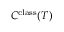Convert formula to latex. <formula><loc_0><loc_0><loc_500><loc_500>C ^ { c l a s s } ( T )</formula> 